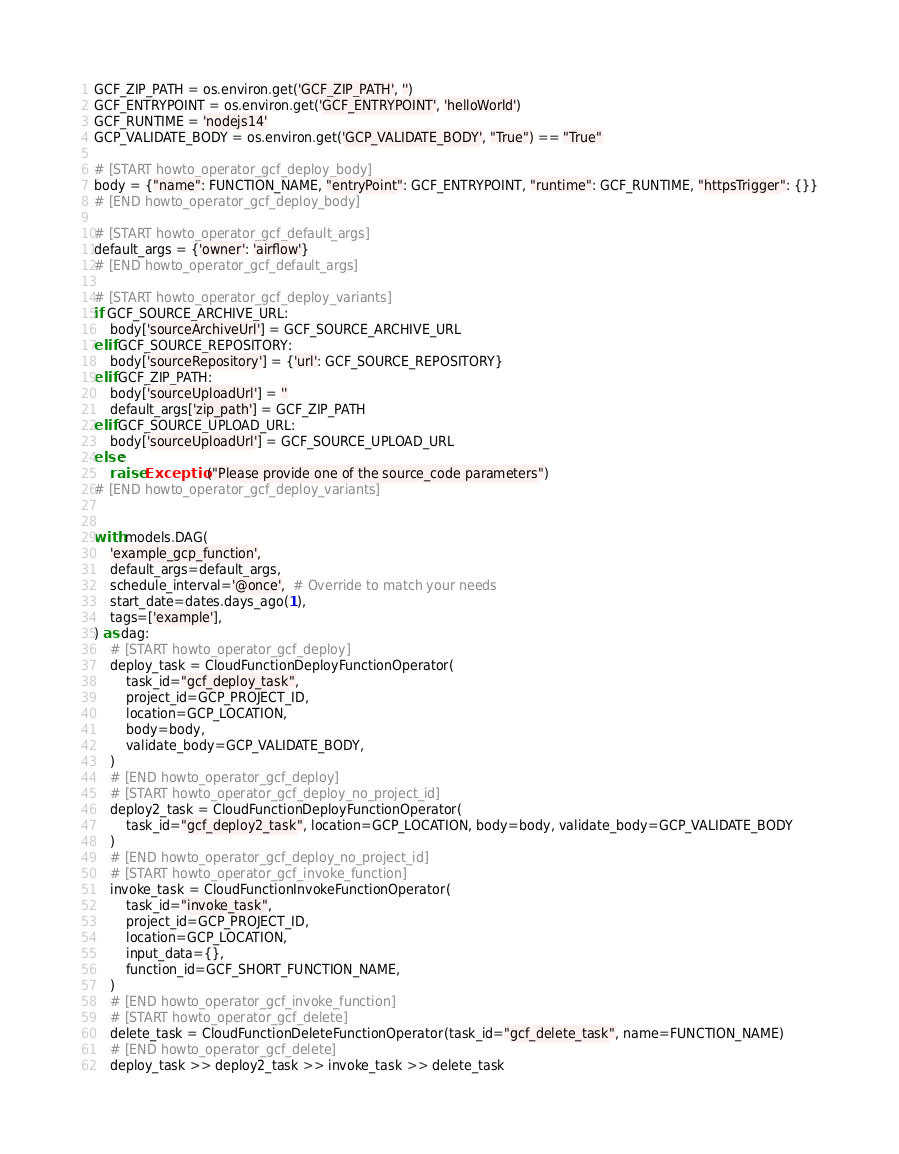<code> <loc_0><loc_0><loc_500><loc_500><_Python_>GCF_ZIP_PATH = os.environ.get('GCF_ZIP_PATH', '')
GCF_ENTRYPOINT = os.environ.get('GCF_ENTRYPOINT', 'helloWorld')
GCF_RUNTIME = 'nodejs14'
GCP_VALIDATE_BODY = os.environ.get('GCP_VALIDATE_BODY', "True") == "True"

# [START howto_operator_gcf_deploy_body]
body = {"name": FUNCTION_NAME, "entryPoint": GCF_ENTRYPOINT, "runtime": GCF_RUNTIME, "httpsTrigger": {}}
# [END howto_operator_gcf_deploy_body]

# [START howto_operator_gcf_default_args]
default_args = {'owner': 'airflow'}
# [END howto_operator_gcf_default_args]

# [START howto_operator_gcf_deploy_variants]
if GCF_SOURCE_ARCHIVE_URL:
    body['sourceArchiveUrl'] = GCF_SOURCE_ARCHIVE_URL
elif GCF_SOURCE_REPOSITORY:
    body['sourceRepository'] = {'url': GCF_SOURCE_REPOSITORY}
elif GCF_ZIP_PATH:
    body['sourceUploadUrl'] = ''
    default_args['zip_path'] = GCF_ZIP_PATH
elif GCF_SOURCE_UPLOAD_URL:
    body['sourceUploadUrl'] = GCF_SOURCE_UPLOAD_URL
else:
    raise Exception("Please provide one of the source_code parameters")
# [END howto_operator_gcf_deploy_variants]


with models.DAG(
    'example_gcp_function',
    default_args=default_args,
    schedule_interval='@once',  # Override to match your needs
    start_date=dates.days_ago(1),
    tags=['example'],
) as dag:
    # [START howto_operator_gcf_deploy]
    deploy_task = CloudFunctionDeployFunctionOperator(
        task_id="gcf_deploy_task",
        project_id=GCP_PROJECT_ID,
        location=GCP_LOCATION,
        body=body,
        validate_body=GCP_VALIDATE_BODY,
    )
    # [END howto_operator_gcf_deploy]
    # [START howto_operator_gcf_deploy_no_project_id]
    deploy2_task = CloudFunctionDeployFunctionOperator(
        task_id="gcf_deploy2_task", location=GCP_LOCATION, body=body, validate_body=GCP_VALIDATE_BODY
    )
    # [END howto_operator_gcf_deploy_no_project_id]
    # [START howto_operator_gcf_invoke_function]
    invoke_task = CloudFunctionInvokeFunctionOperator(
        task_id="invoke_task",
        project_id=GCP_PROJECT_ID,
        location=GCP_LOCATION,
        input_data={},
        function_id=GCF_SHORT_FUNCTION_NAME,
    )
    # [END howto_operator_gcf_invoke_function]
    # [START howto_operator_gcf_delete]
    delete_task = CloudFunctionDeleteFunctionOperator(task_id="gcf_delete_task", name=FUNCTION_NAME)
    # [END howto_operator_gcf_delete]
    deploy_task >> deploy2_task >> invoke_task >> delete_task
</code> 